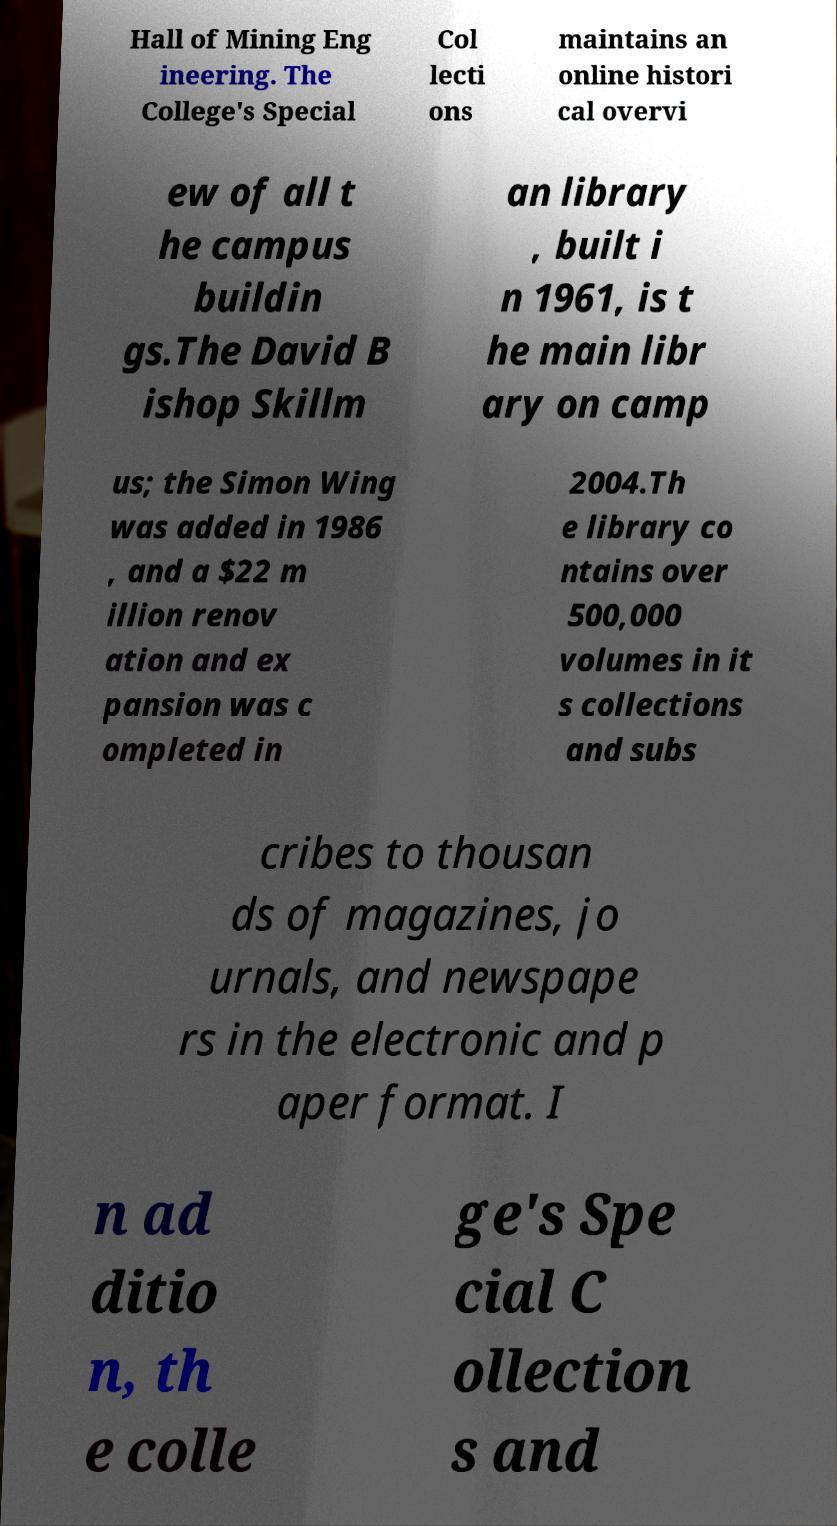Can you accurately transcribe the text from the provided image for me? Hall of Mining Eng ineering. The College's Special Col lecti ons maintains an online histori cal overvi ew of all t he campus buildin gs.The David B ishop Skillm an library , built i n 1961, is t he main libr ary on camp us; the Simon Wing was added in 1986 , and a $22 m illion renov ation and ex pansion was c ompleted in 2004.Th e library co ntains over 500,000 volumes in it s collections and subs cribes to thousan ds of magazines, jo urnals, and newspape rs in the electronic and p aper format. I n ad ditio n, th e colle ge's Spe cial C ollection s and 